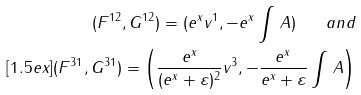Convert formula to latex. <formula><loc_0><loc_0><loc_500><loc_500>( F ^ { 1 2 } , G ^ { 1 2 } ) = ( e ^ { x } v ^ { 1 } , - e ^ { x } \int \, A ) \quad a n d \\ [ 1 . 5 e x ] ( F ^ { 3 1 } , G ^ { 3 1 } ) = \left ( \frac { e ^ { x } } { ( e ^ { x } + \varepsilon ) ^ { 2 } } v ^ { 3 } , - \frac { e ^ { x } } { e ^ { x } + \varepsilon } \int \, A \right )</formula> 